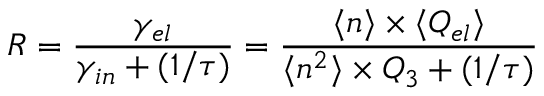<formula> <loc_0><loc_0><loc_500><loc_500>R = \frac { \gamma _ { e l } } { \gamma _ { i n } + ( 1 / \tau ) } = \frac { \langle n \rangle \times \langle Q _ { e l } \rangle } { \langle n ^ { 2 } \rangle \times Q _ { 3 } + ( 1 / \tau ) }</formula> 